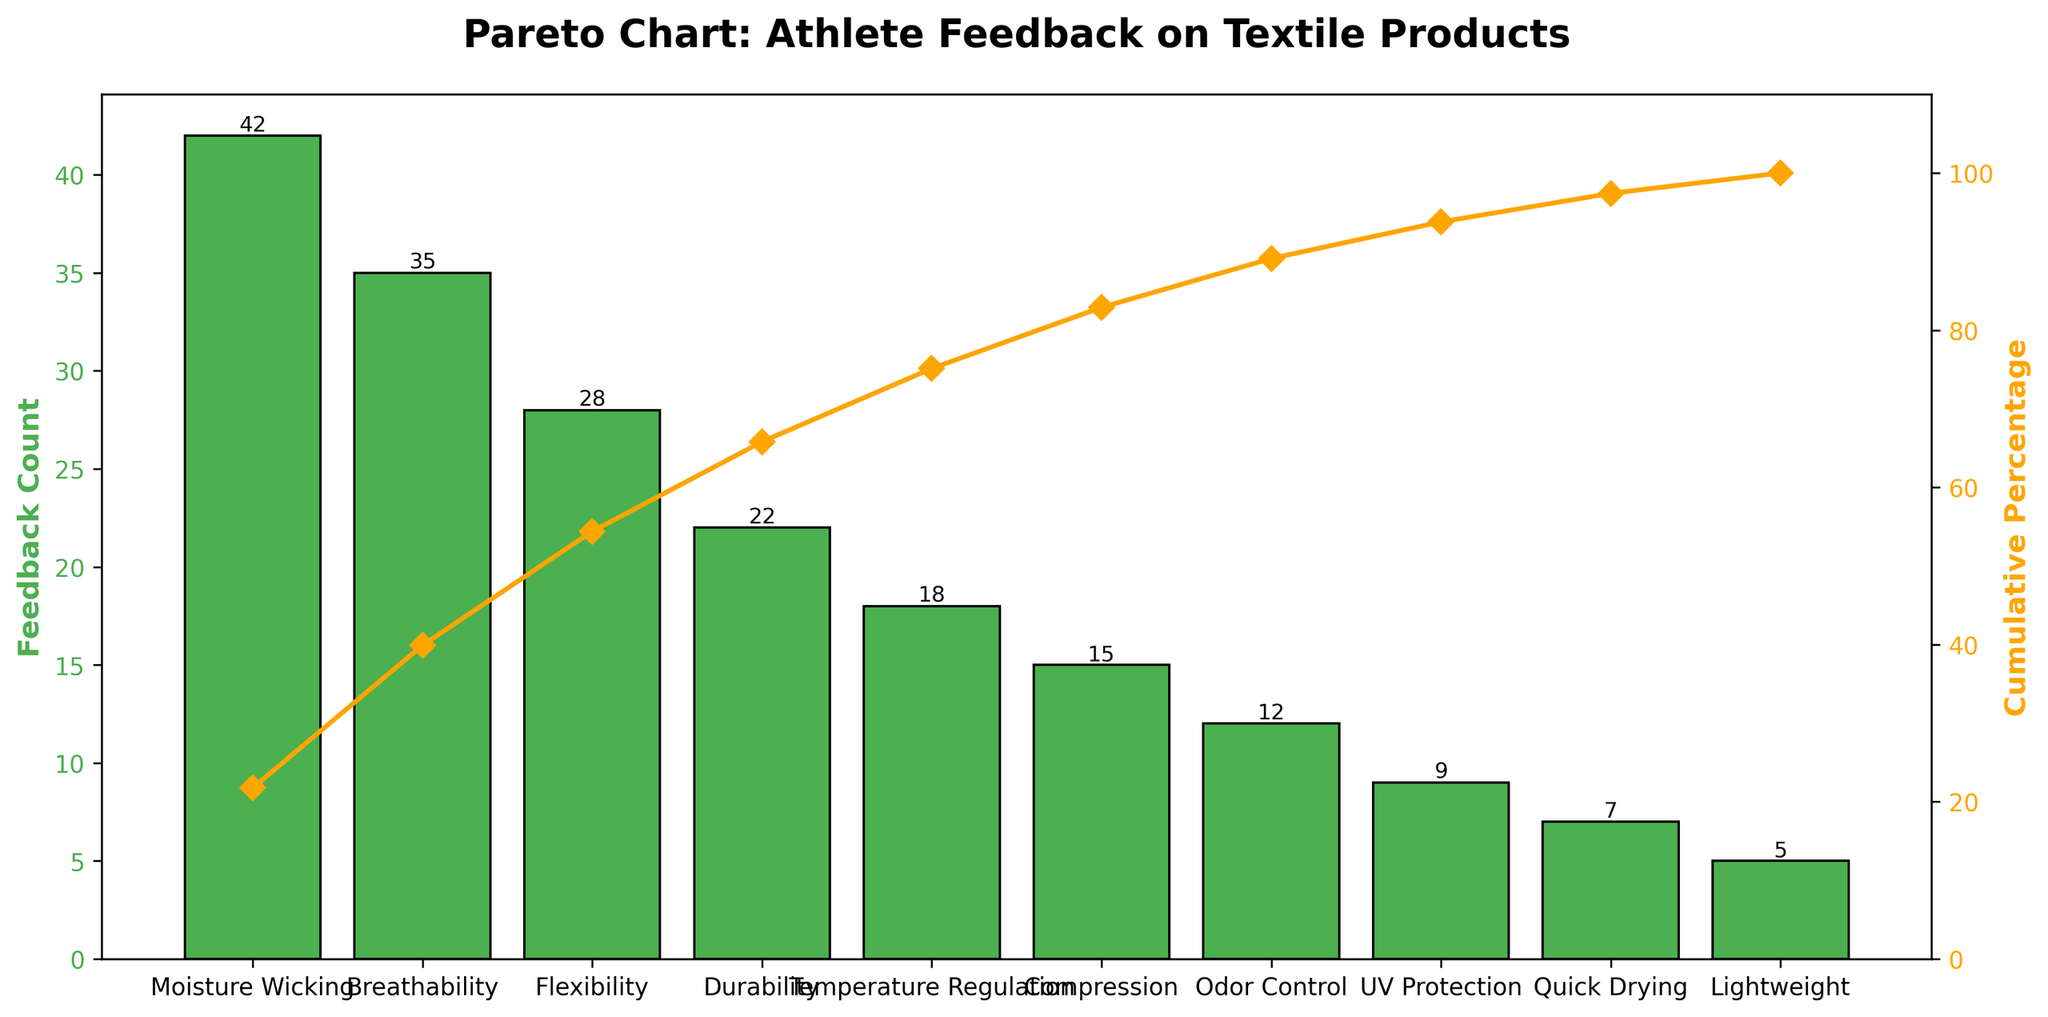How many performance aspects are listed in the figure? Count the number of unique performance aspects listed on the x-axis. The aspects are Moisture Wicking, Breathability, Flexibility, Durability, Temperature Regulation, Compression, Odor Control, UV Protection, Quick Drying, and Lightweight.
Answer: 10 Which performance aspect received the highest feedback count? Look for the tallest bar in the figure, which represents the highest feedback count.
Answer: Moisture Wicking What is the cumulative percentage for "Breathability"? Identify the line plot point corresponding to "Breathability" on the x-axis and read the cumulative percentage value from the secondary y-axis.
Answer: ~58% What is the combined feedback count for "Flexibility" and "Durability"? Sum the feedback counts for "Flexibility" (28) and "Durability" (22).
Answer: 50 How does the feedback count for "Odor Control" compare to "Temperature Regulation"? Check the heights of the bars for "Odor Control" (12) and "Temperature Regulation" (18). Subtract the smaller count from the larger one.
Answer: 6 less What percentage of feedback does "Compression" comprise of the total feedback count? Divide the feedback count for "Compression" (15) by the total feedback count (193), then multiply by 100 to get the percentage.
Answer: ~7.8% Which two performance aspects together reach about 50% cumulative feedback percentage? Locate where the cumulative percentage line hits around 50%. The first two aspects are Moisture Wicking and Breathability.
Answer: Moisture Wicking and Breathability What is the approximate difference in cumulative percentage between "UV Protection" and "Quick Drying"? Find the cumulative percentages of "UV Protection" (~95%) and "Quick Drying" (~98%) and subtract the smaller value from the larger one.
Answer: ~3% Is the cumulative percentage of feedback for "Lightweight" above the 90% mark? Check the cumulative percentage line graph point for "Lightweight" and see if it is above 90% on the secondary y-axis.
Answer: Yes What is the average feedback count for the shown performance aspects? Sum all feedback counts (42+35+28+22+18+15+12+9+7+5 = 193) and divide by the number of aspects (10).
Answer: 19.3 